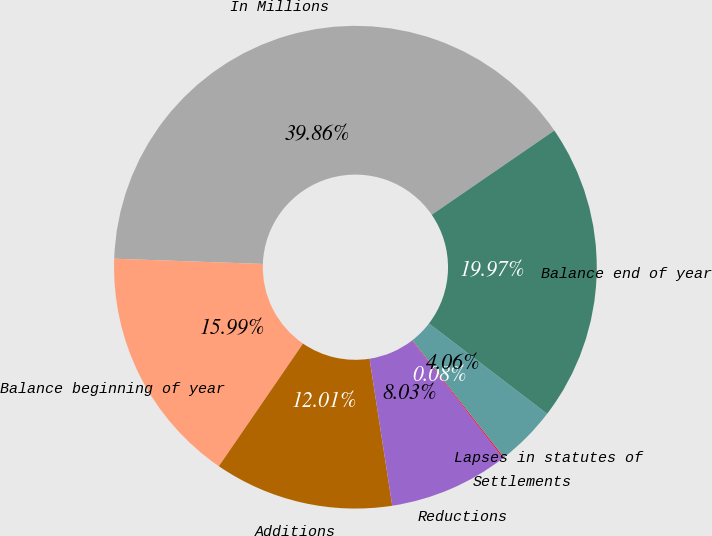Convert chart to OTSL. <chart><loc_0><loc_0><loc_500><loc_500><pie_chart><fcel>In Millions<fcel>Balance beginning of year<fcel>Additions<fcel>Reductions<fcel>Settlements<fcel>Lapses in statutes of<fcel>Balance end of year<nl><fcel>39.86%<fcel>15.99%<fcel>12.01%<fcel>8.03%<fcel>0.08%<fcel>4.06%<fcel>19.97%<nl></chart> 